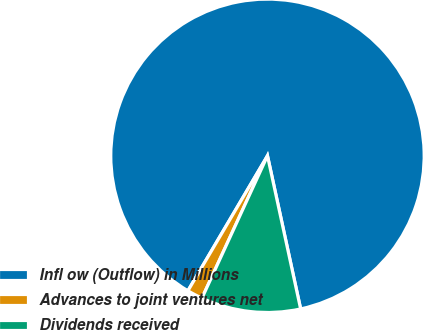<chart> <loc_0><loc_0><loc_500><loc_500><pie_chart><fcel>Infl ow (Outflow) in Millions<fcel>Advances to joint ventures net<fcel>Dividends received<nl><fcel>88.13%<fcel>1.61%<fcel>10.26%<nl></chart> 